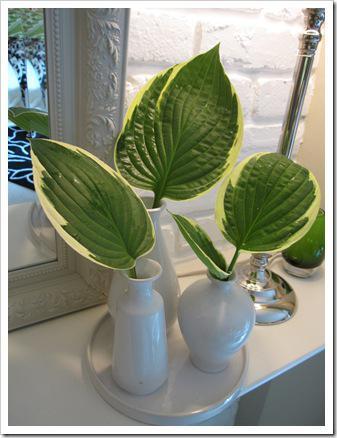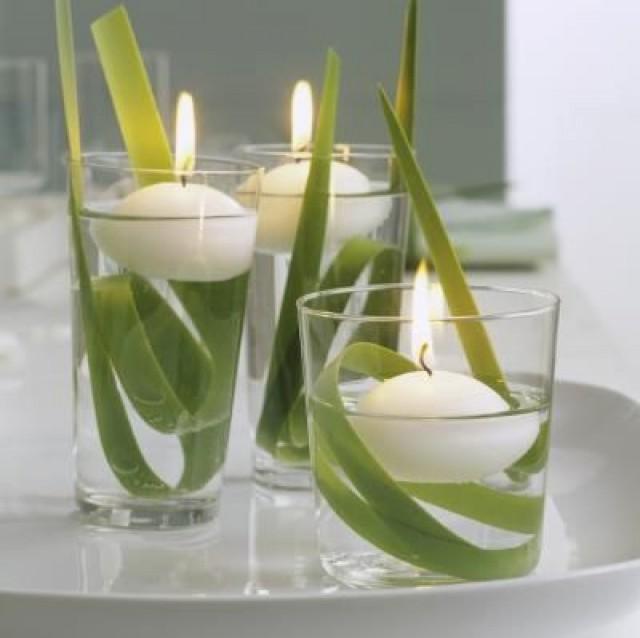The first image is the image on the left, the second image is the image on the right. For the images displayed, is the sentence "An image shows several clear glasses on a wood surface, and at least one contains a variegated green-and-whitish leaf." factually correct? Answer yes or no. No. The first image is the image on the left, the second image is the image on the right. Analyze the images presented: Is the assertion "There are plants in drinking glasses, one of which is short." valid? Answer yes or no. Yes. 